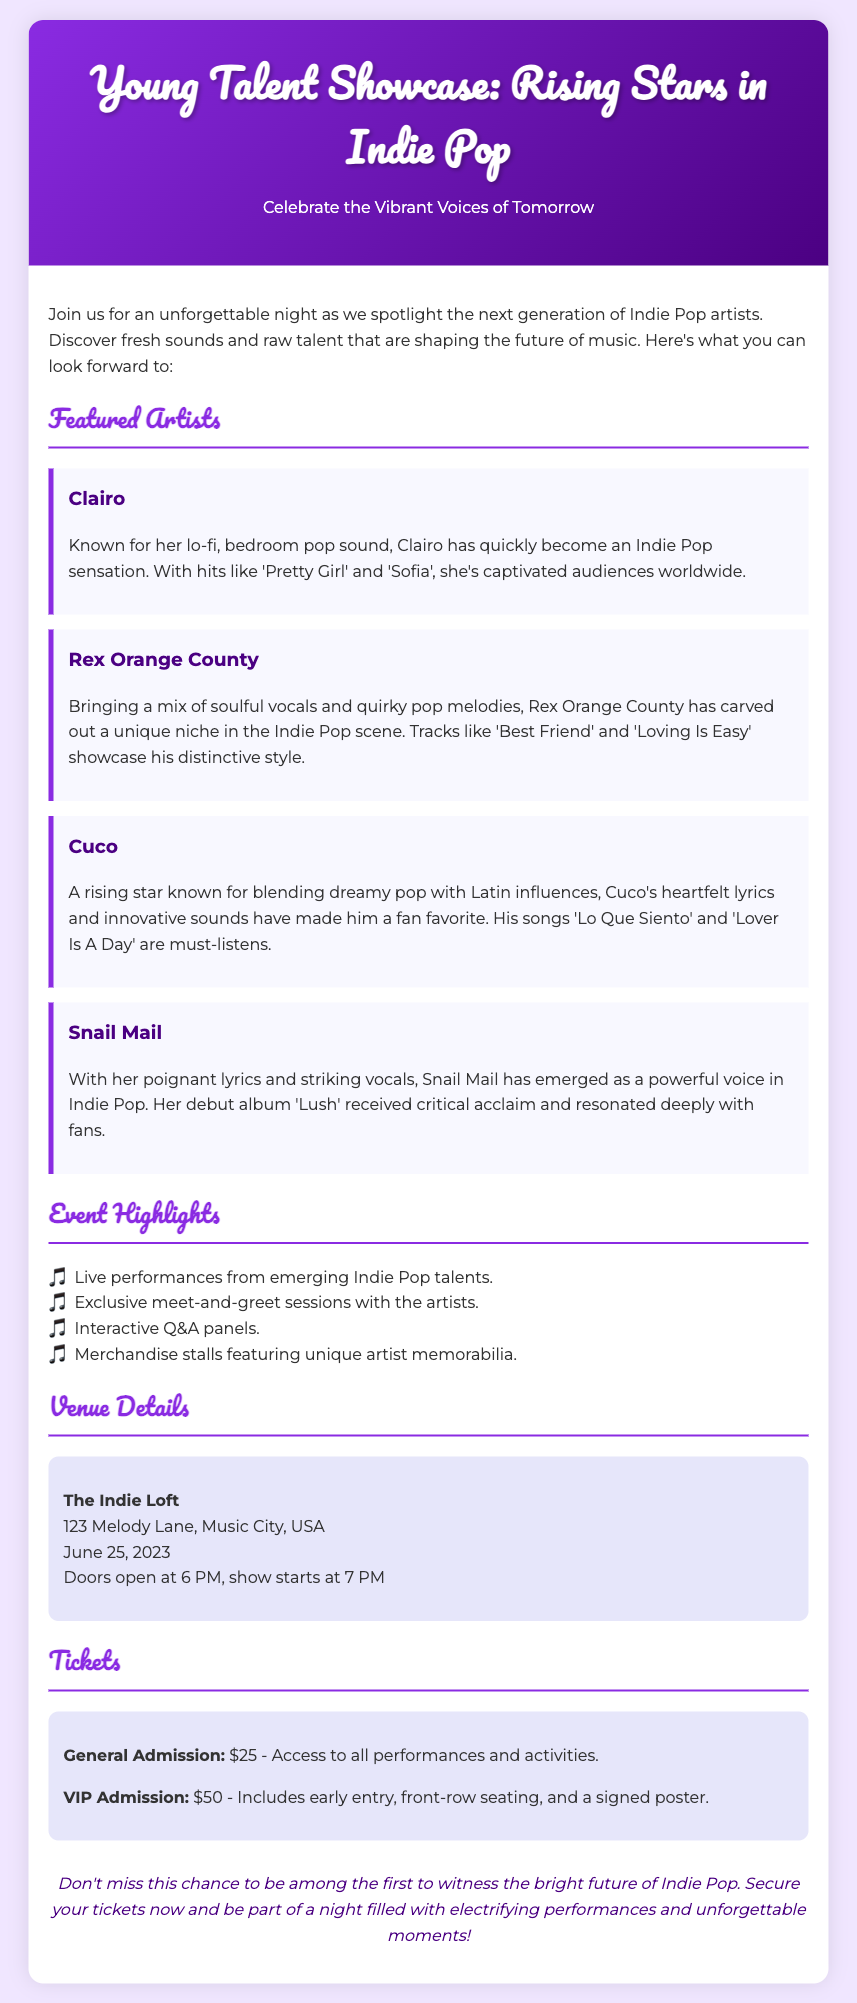What is the title of the event? The title of the event is displayed prominently at the top of the document.
Answer: Young Talent Showcase: Rising Stars in Indie Pop When will the event take place? The date of the event is mentioned in the venue details section of the document.
Answer: June 25, 2023 Who is one of the featured artists? The document lists several artists in the featured artists section, providing their names.
Answer: Clairo What is the price for VIP admission? The ticket prices are clearly outlined in the tickets section of the document.
Answer: $50 Where is the event venue located? The venue details specify the address of the location in the document.
Answer: 123 Melody Lane, Music City, USA What type of music will be showcased? The event specifically highlights the genre of music being featured in the description.
Answer: Indie Pop What is included in VIP admission? The document outlines what attendees receive when they purchase VIP tickets in the tickets section.
Answer: Early entry, front-row seating, and a signed poster Name one event highlight. The highlights are listed in bullet points in the event highlights section of the document.
Answer: Live performances from emerging Indie Pop talents What is the main purpose of the event? The introductory paragraph summarizes the aim of the event, focusing on the youth in music.
Answer: Spotlight the next generation of Indie Pop artists 